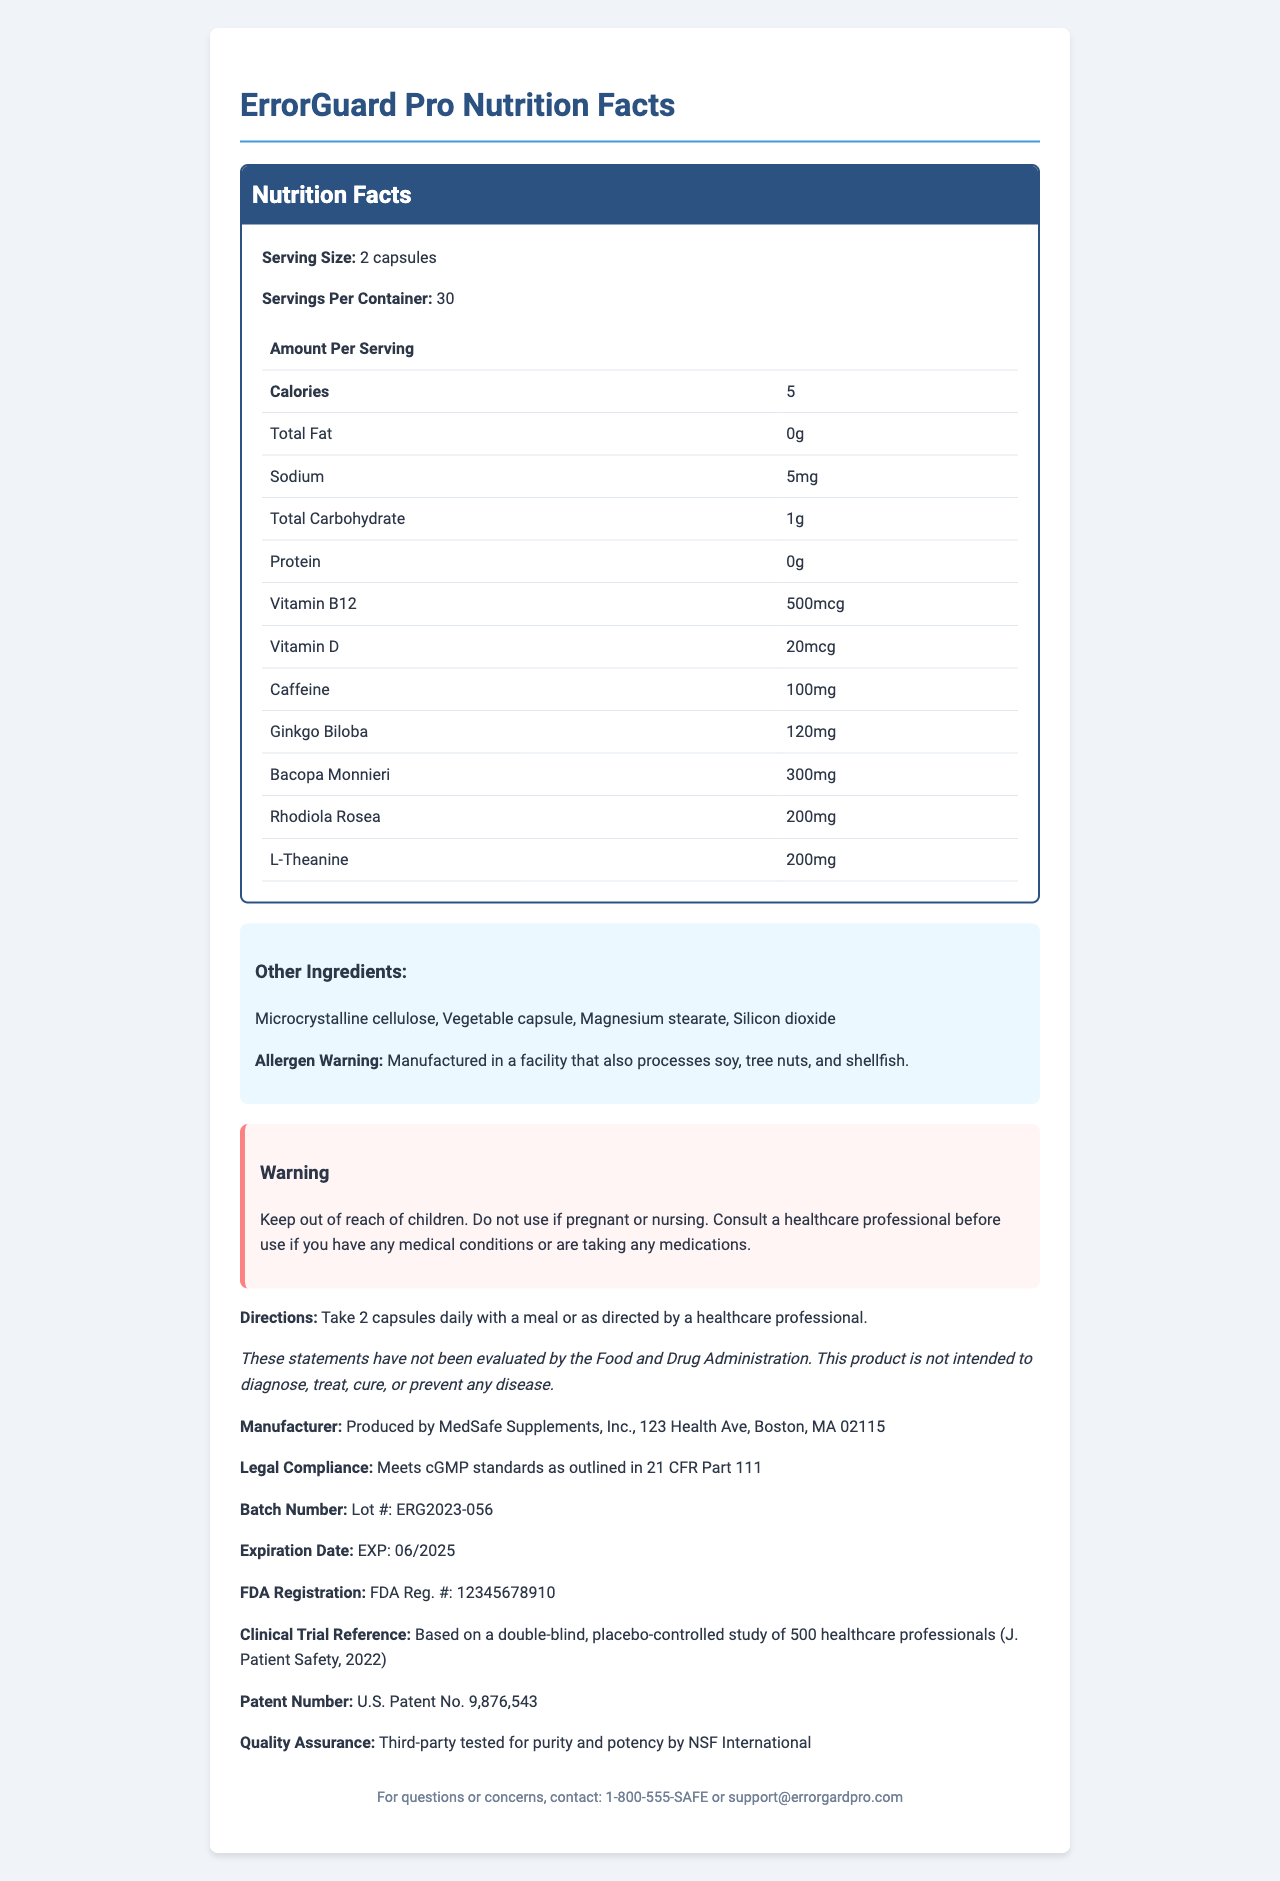what is the serving size for ErrorGuard Pro? The serving size is listed as "2 capsules" in the Nutrition Facts section of the document.
Answer: 2 capsules how many servings are there per container? The document states that there are 30 servings per container.
Answer: 30 what is the amount of caffeine per serving? The document lists 100mg of caffeine per serving in the Nutrition Facts section.
Answer: 100mg what are the allergens mentioned in the warning? The allergen warning specifically mentions that the product is manufactured in a facility that processes soy, tree nuts, and shellfish.
Answer: Soy, tree nuts, and shellfish what is the expiration date of ErrorGuard Pro? The expiration date is mentioned as "EXP: 06/2025" in the document.
Answer: EXP: 06/2025 what should you do before using this product if you are taking medications? The warning statement advises consulting a healthcare professional before using the product if you have any medical conditions or are taking medications.
Answer: Consult a healthcare professional what is the FDA registration number for ErrorGuard Pro? The FDA registration number found in the document is "FDA Reg. #: 12345678910."
Answer: FDA Reg. #: 12345678910 identify the correct serving size for ErrorGuard Pro.
A. 1 capsule
B. 2 capsules
C. 3 capsules
D. 4 capsules The serving size listed for ErrorGuard Pro is "2 capsules."
Answer: B how much Vitamin B12 is in each serving of ErrorGuard Pro?
A. 10mcg
B. 100mcg
C. 250mcg
D. 500mcg The Nutrition Facts section states that there is 500mcg of Vitamin B12 per serving.
Answer: D is it appropriate to use ErrorGuard Pro while nursing? The warning statement specifies not to use the product if pregnant or nursing.
Answer: No summarize the main idea of the document. The document is comprehensive in detailing the information about ErrorGuard Pro, including its ingredients, nutrition facts, manufacturing and safety assurances, usage directions, and various warnings and disclaimers.
Answer: The document provides detailed nutritional information for ErrorGuard Pro, a dietary supplement designed to reduce medical errors. It includes serving size, ingredients, allergen warnings, directions for use, manufacturer details, and legal compliance information. It also highlights various vitamins, caffeine, and herbal supplements included in the product, as well as necessary precautions and disclaimers. what is the daily calorie intake from one serving? According to the Nutrition Facts, one serving of ErrorGuard Pro contains 5 calories.
Answer: 5 calories can I safely use ErrorGuard Pro if I have a nut allergy? The allergen warning indicates that the product is manufactured in a facility that processes tree nuts, making it unsafe for someone with a nut allergy.
Answer: No is MedSafe Supplements, Inc. the manufacturer of this product? The document confirms that ErrorGuard Pro is produced by MedSafe Supplements, Inc.
Answer: Yes where is MedSafe Supplements, Inc. located? The manufacturer information section states the address as "123 Health Ave, Boston, MA 02115."
Answer: 123 Health Ave, Boston, MA 02115 what incentives are there for healthcare professionals to use ErrorGuard Pro? The document does not provide information on incentives specifically for healthcare professionals to use the product.
Answer: Cannot be determined 